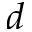Convert formula to latex. <formula><loc_0><loc_0><loc_500><loc_500>d</formula> 